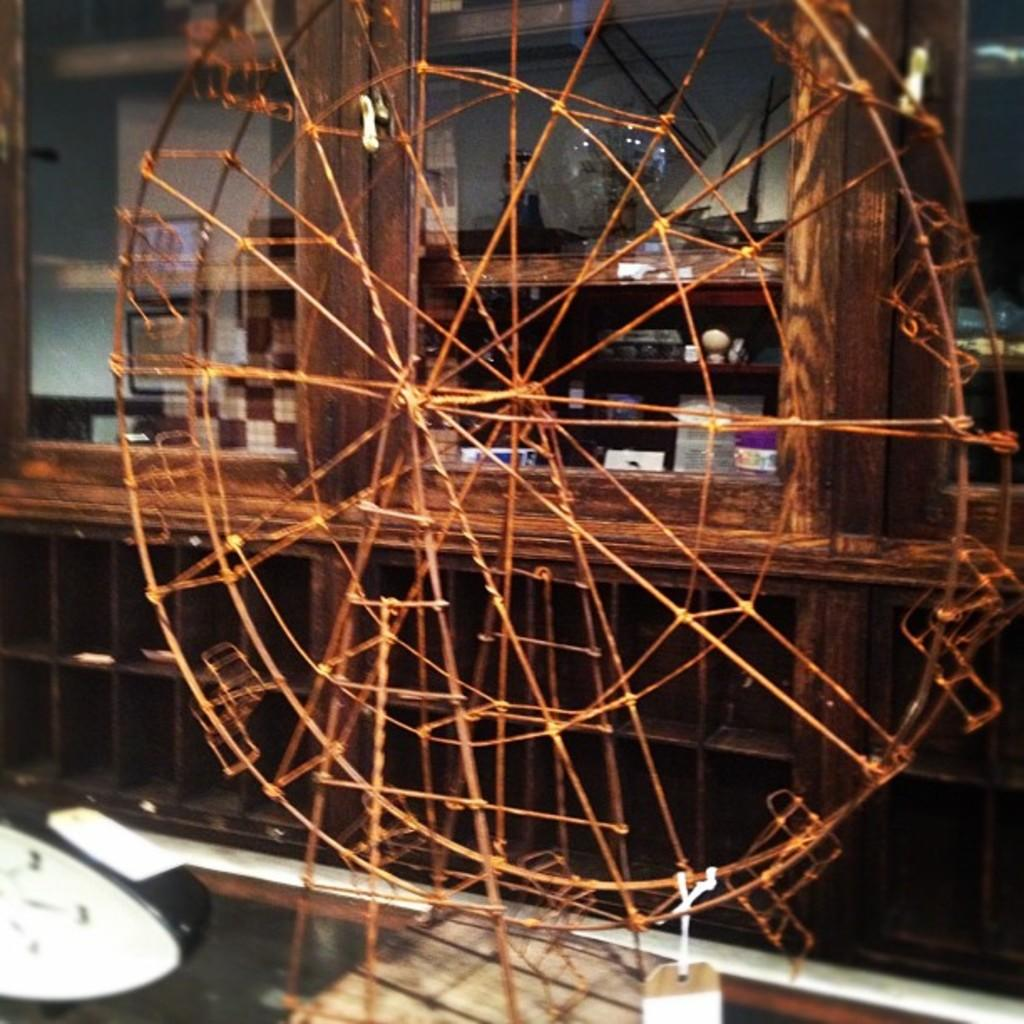What is the main subject in the center of the image? There is a ferris wheel in the center of the image. Can you describe anything visible in the background of the image? There is a glass visible in the background of the image. Where is the curtain located in the image? There is no curtain present in the image. Can you see a fireman operating the ferris wheel in the image? There is no fireman or any indication of a fireman operating the ferris wheel in the image. 